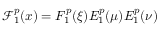<formula> <loc_0><loc_0><loc_500><loc_500>\mathcal { F } _ { 1 } ^ { p } ( x ) = F _ { 1 } ^ { p } ( \xi ) E _ { 1 } ^ { p } ( \mu ) E _ { 1 } ^ { p } ( \nu )</formula> 